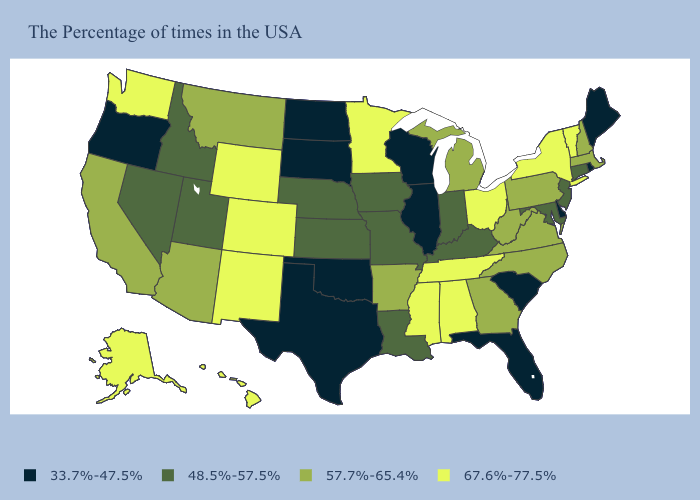What is the value of North Dakota?
Quick response, please. 33.7%-47.5%. Name the states that have a value in the range 67.6%-77.5%?
Give a very brief answer. Vermont, New York, Ohio, Alabama, Tennessee, Mississippi, Minnesota, Wyoming, Colorado, New Mexico, Washington, Alaska, Hawaii. Name the states that have a value in the range 48.5%-57.5%?
Answer briefly. Connecticut, New Jersey, Maryland, Kentucky, Indiana, Louisiana, Missouri, Iowa, Kansas, Nebraska, Utah, Idaho, Nevada. What is the value of West Virginia?
Keep it brief. 57.7%-65.4%. Does Oregon have the lowest value in the West?
Concise answer only. Yes. Which states have the lowest value in the USA?
Keep it brief. Maine, Rhode Island, Delaware, South Carolina, Florida, Wisconsin, Illinois, Oklahoma, Texas, South Dakota, North Dakota, Oregon. What is the value of West Virginia?
Quick response, please. 57.7%-65.4%. Name the states that have a value in the range 33.7%-47.5%?
Short answer required. Maine, Rhode Island, Delaware, South Carolina, Florida, Wisconsin, Illinois, Oklahoma, Texas, South Dakota, North Dakota, Oregon. What is the value of Connecticut?
Answer briefly. 48.5%-57.5%. What is the value of Hawaii?
Answer briefly. 67.6%-77.5%. Does Rhode Island have a lower value than West Virginia?
Give a very brief answer. Yes. Does New Jersey have the lowest value in the Northeast?
Give a very brief answer. No. What is the value of Georgia?
Keep it brief. 57.7%-65.4%. Name the states that have a value in the range 48.5%-57.5%?
Quick response, please. Connecticut, New Jersey, Maryland, Kentucky, Indiana, Louisiana, Missouri, Iowa, Kansas, Nebraska, Utah, Idaho, Nevada. Does Minnesota have the highest value in the MidWest?
Answer briefly. Yes. 